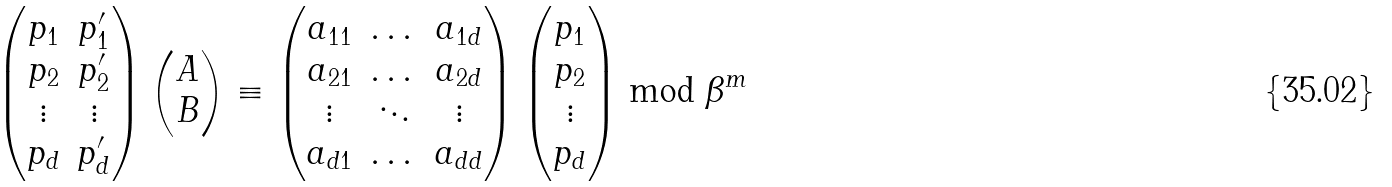<formula> <loc_0><loc_0><loc_500><loc_500>\left ( \begin{matrix} p _ { 1 } & p ^ { \prime } _ { 1 } \\ p _ { 2 } & p ^ { \prime } _ { 2 } \\ \vdots & \vdots \\ p _ { d } & p ^ { \prime } _ { d } \\ \end{matrix} \right ) \left ( \begin{matrix} A \\ B \end{matrix} \right ) \equiv \left ( \begin{matrix} a _ { 1 1 } & \dots & a _ { 1 d } \\ a _ { 2 1 } & \dots & a _ { 2 d } \\ \vdots & \ddots & \vdots \\ a _ { d 1 } & \dots & a _ { d d } \end{matrix} \right ) \left ( \begin{matrix} p _ { 1 } \\ p _ { 2 } \\ \vdots \\ p _ { d } \end{matrix} \right ) \bmod \beta ^ { m }</formula> 